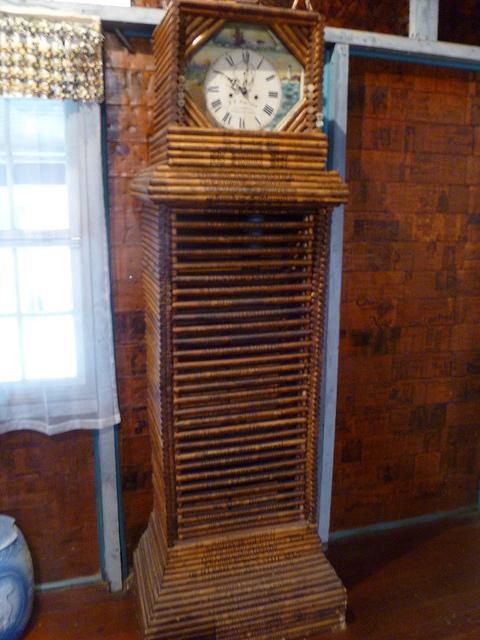How many clocks are there?
Give a very brief answer. 1. How many people can eat at the counter?
Give a very brief answer. 0. 